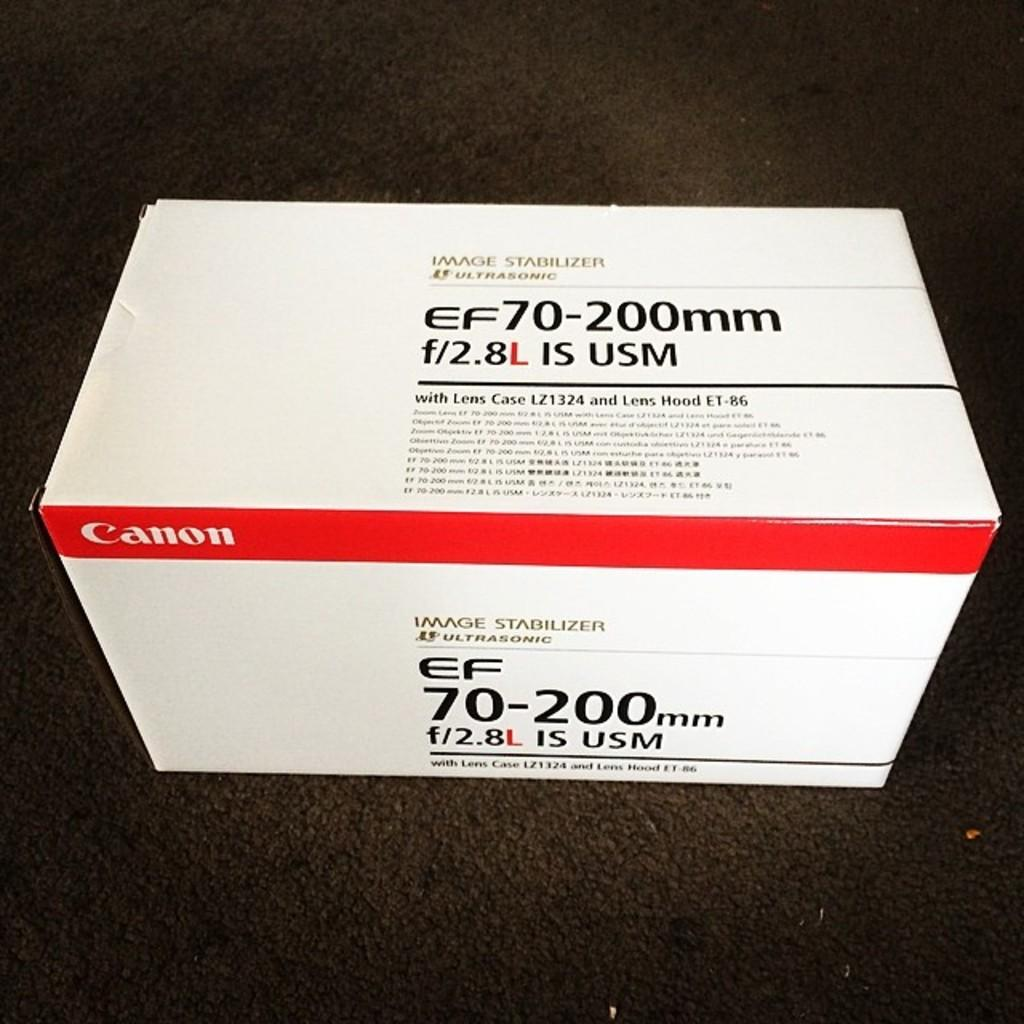<image>
Relay a brief, clear account of the picture shown. The Canon Ultrasonic Image Stabilizer EF 70-200mm is in it's original box and in stock. 